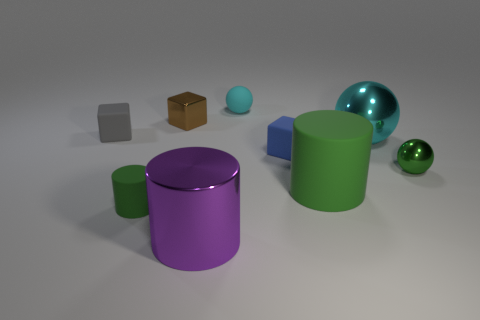What material is the small green thing on the left side of the small sphere left of the small matte block that is on the right side of the cyan matte sphere?
Your answer should be very brief. Rubber. There is a gray thing that is the same size as the brown block; what is its shape?
Your answer should be compact. Cube. Are there any cubes that have the same color as the small rubber ball?
Your answer should be compact. No. The metallic cylinder has what size?
Offer a terse response. Large. Is the material of the small blue object the same as the small cyan thing?
Offer a very short reply. Yes. How many large green rubber cylinders are right of the tiny green object on the right side of the tiny green thing to the left of the big purple cylinder?
Offer a very short reply. 0. What shape is the green thing that is to the left of the tiny brown shiny block?
Provide a short and direct response. Cylinder. What number of other things are there of the same material as the tiny green ball
Ensure brevity in your answer.  3. Is the small shiny block the same color as the rubber sphere?
Your answer should be very brief. No. Are there fewer tiny balls that are left of the tiny cyan matte sphere than tiny gray cubes right of the blue rubber thing?
Your answer should be very brief. No. 